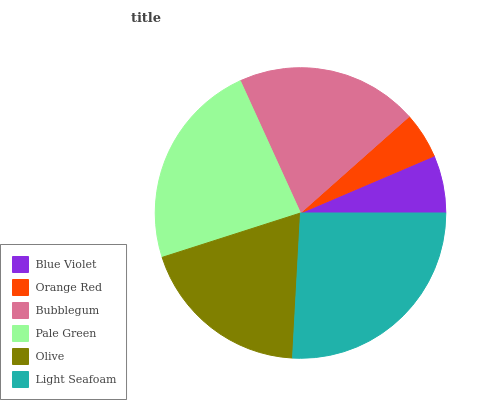Is Orange Red the minimum?
Answer yes or no. Yes. Is Light Seafoam the maximum?
Answer yes or no. Yes. Is Bubblegum the minimum?
Answer yes or no. No. Is Bubblegum the maximum?
Answer yes or no. No. Is Bubblegum greater than Orange Red?
Answer yes or no. Yes. Is Orange Red less than Bubblegum?
Answer yes or no. Yes. Is Orange Red greater than Bubblegum?
Answer yes or no. No. Is Bubblegum less than Orange Red?
Answer yes or no. No. Is Bubblegum the high median?
Answer yes or no. Yes. Is Olive the low median?
Answer yes or no. Yes. Is Light Seafoam the high median?
Answer yes or no. No. Is Pale Green the low median?
Answer yes or no. No. 